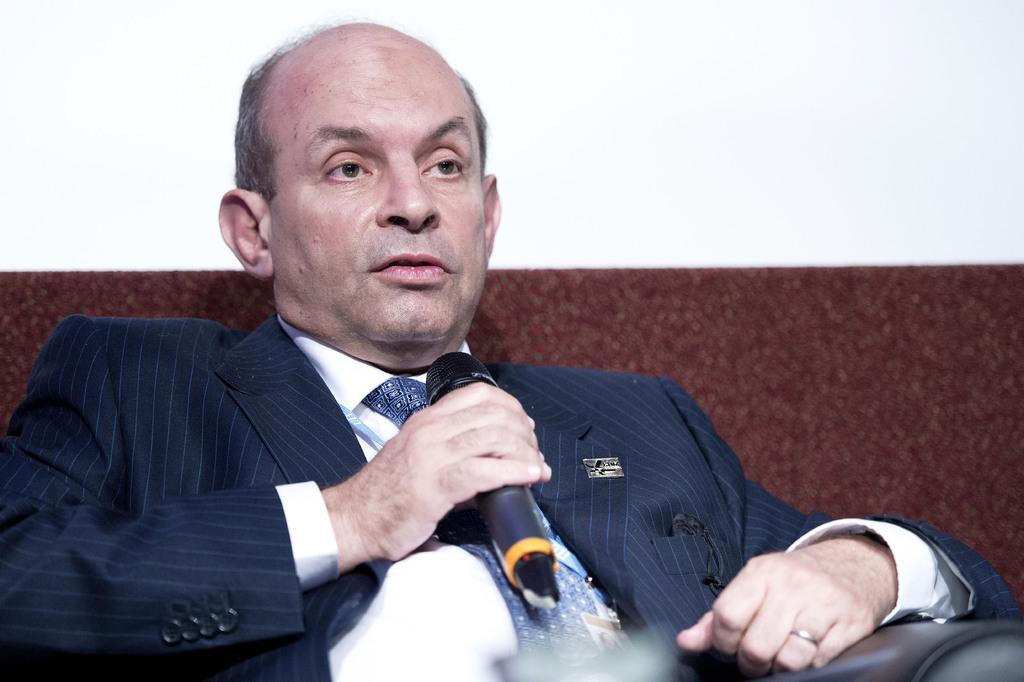Can you describe this image briefly? In this picture there is a man who is wearing white shirt , and blue tie and a blue suit. He is holding a mic in his hand. 